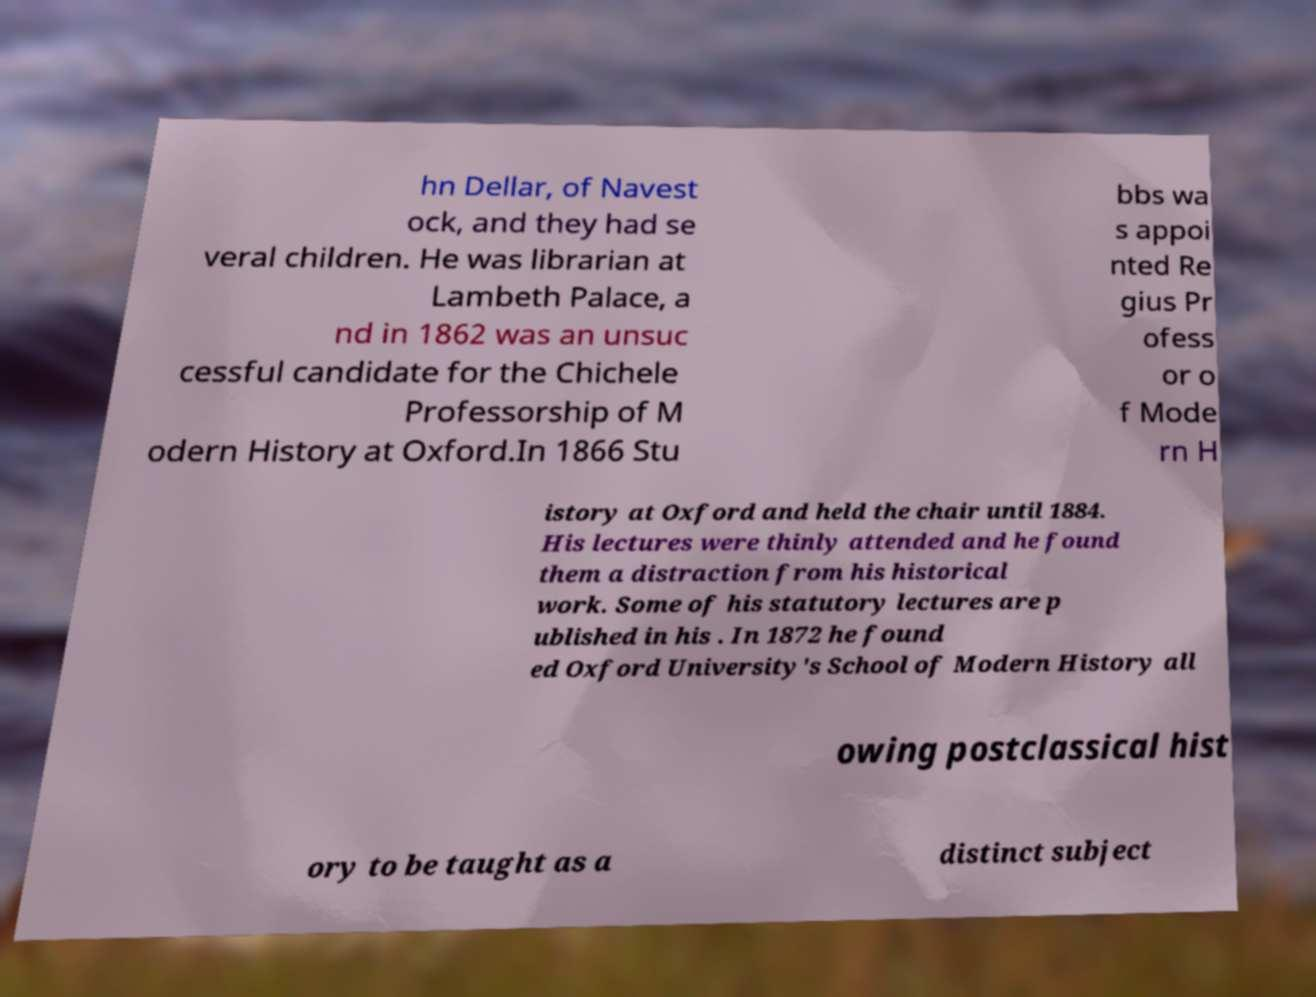Could you assist in decoding the text presented in this image and type it out clearly? hn Dellar, of Navest ock, and they had se veral children. He was librarian at Lambeth Palace, a nd in 1862 was an unsuc cessful candidate for the Chichele Professorship of M odern History at Oxford.In 1866 Stu bbs wa s appoi nted Re gius Pr ofess or o f Mode rn H istory at Oxford and held the chair until 1884. His lectures were thinly attended and he found them a distraction from his historical work. Some of his statutory lectures are p ublished in his . In 1872 he found ed Oxford University's School of Modern History all owing postclassical hist ory to be taught as a distinct subject 